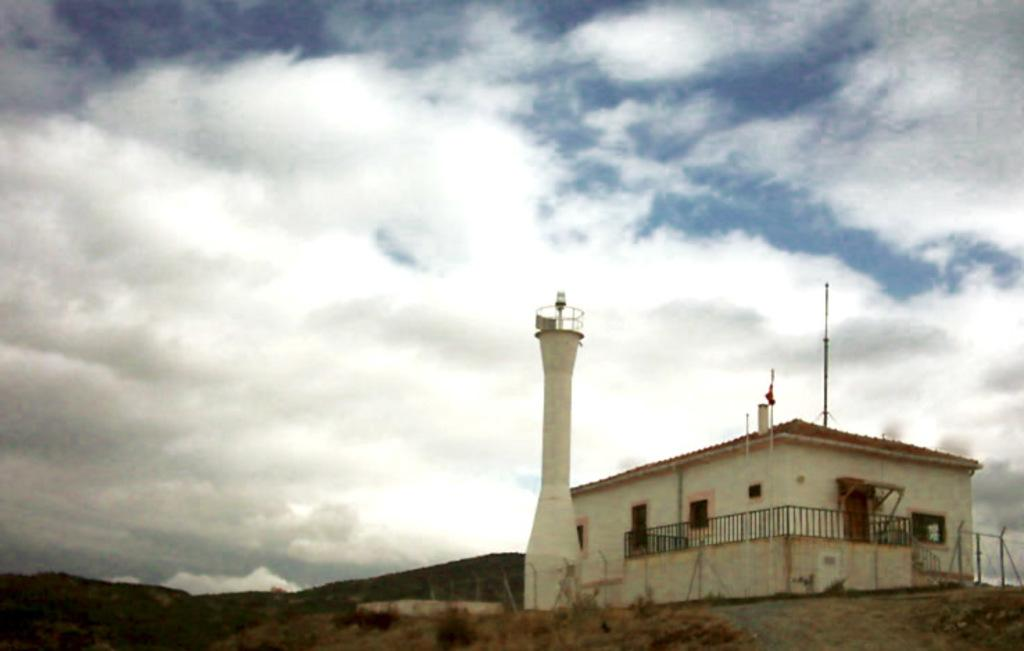What type of building can be seen in the image? There is a white shed house in the image. What other structure is visible in the image? There is a lighthouse in the image. How are the shed house and the lighthouse positioned in relation to each other? The lighthouse is in the front of the shed house. What can be seen in the sky in the image? The sky is visible in the image, and clouds are present. What type of ring is being worn by the dolls in the image? There are no dolls present in the image, so there is no ring to be worn by any dolls. 